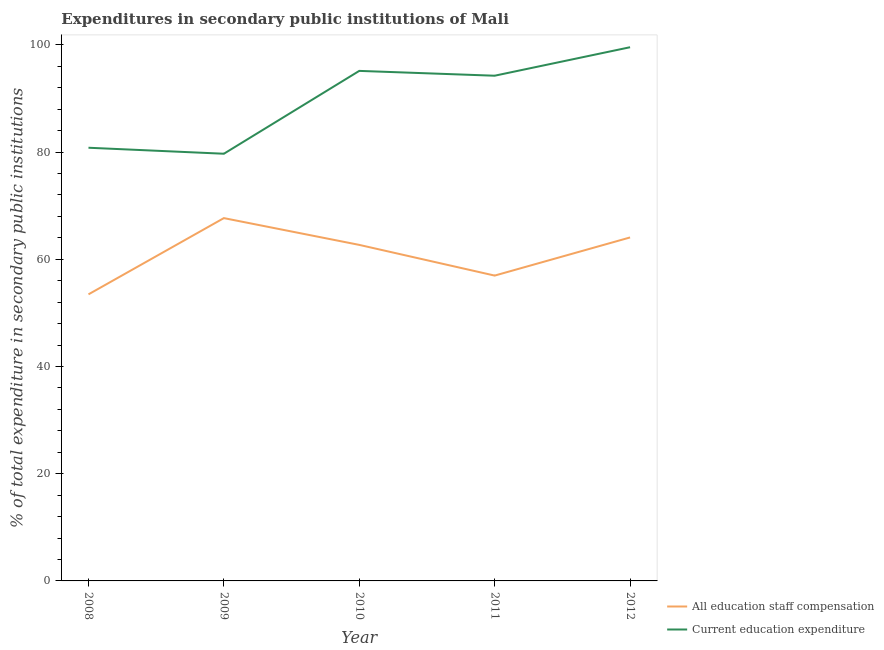How many different coloured lines are there?
Make the answer very short. 2. Is the number of lines equal to the number of legend labels?
Keep it short and to the point. Yes. What is the expenditure in staff compensation in 2012?
Make the answer very short. 64.07. Across all years, what is the maximum expenditure in education?
Offer a very short reply. 99.55. Across all years, what is the minimum expenditure in staff compensation?
Offer a terse response. 53.46. In which year was the expenditure in staff compensation minimum?
Provide a short and direct response. 2008. What is the total expenditure in education in the graph?
Provide a succinct answer. 449.43. What is the difference between the expenditure in staff compensation in 2008 and that in 2010?
Keep it short and to the point. -9.23. What is the difference between the expenditure in education in 2011 and the expenditure in staff compensation in 2009?
Offer a very short reply. 26.56. What is the average expenditure in education per year?
Your answer should be very brief. 89.89. In the year 2008, what is the difference between the expenditure in education and expenditure in staff compensation?
Offer a terse response. 27.35. What is the ratio of the expenditure in staff compensation in 2010 to that in 2012?
Ensure brevity in your answer.  0.98. Is the expenditure in education in 2008 less than that in 2010?
Your answer should be compact. Yes. What is the difference between the highest and the second highest expenditure in staff compensation?
Give a very brief answer. 3.61. What is the difference between the highest and the lowest expenditure in staff compensation?
Your answer should be compact. 14.22. In how many years, is the expenditure in education greater than the average expenditure in education taken over all years?
Make the answer very short. 3. How many years are there in the graph?
Give a very brief answer. 5. What is the difference between two consecutive major ticks on the Y-axis?
Keep it short and to the point. 20. Does the graph contain any zero values?
Your response must be concise. No. Does the graph contain grids?
Offer a very short reply. No. Where does the legend appear in the graph?
Make the answer very short. Bottom right. What is the title of the graph?
Your response must be concise. Expenditures in secondary public institutions of Mali. Does "Lower secondary rate" appear as one of the legend labels in the graph?
Your answer should be compact. No. What is the label or title of the Y-axis?
Give a very brief answer. % of total expenditure in secondary public institutions. What is the % of total expenditure in secondary public institutions of All education staff compensation in 2008?
Provide a short and direct response. 53.46. What is the % of total expenditure in secondary public institutions of Current education expenditure in 2008?
Your answer should be compact. 80.81. What is the % of total expenditure in secondary public institutions of All education staff compensation in 2009?
Your answer should be very brief. 67.68. What is the % of total expenditure in secondary public institutions in Current education expenditure in 2009?
Your answer should be very brief. 79.69. What is the % of total expenditure in secondary public institutions in All education staff compensation in 2010?
Your answer should be compact. 62.68. What is the % of total expenditure in secondary public institutions in Current education expenditure in 2010?
Offer a terse response. 95.14. What is the % of total expenditure in secondary public institutions in All education staff compensation in 2011?
Make the answer very short. 56.96. What is the % of total expenditure in secondary public institutions of Current education expenditure in 2011?
Your answer should be compact. 94.24. What is the % of total expenditure in secondary public institutions of All education staff compensation in 2012?
Your answer should be very brief. 64.07. What is the % of total expenditure in secondary public institutions of Current education expenditure in 2012?
Keep it short and to the point. 99.55. Across all years, what is the maximum % of total expenditure in secondary public institutions in All education staff compensation?
Keep it short and to the point. 67.68. Across all years, what is the maximum % of total expenditure in secondary public institutions in Current education expenditure?
Offer a terse response. 99.55. Across all years, what is the minimum % of total expenditure in secondary public institutions in All education staff compensation?
Make the answer very short. 53.46. Across all years, what is the minimum % of total expenditure in secondary public institutions in Current education expenditure?
Offer a terse response. 79.69. What is the total % of total expenditure in secondary public institutions of All education staff compensation in the graph?
Offer a terse response. 304.85. What is the total % of total expenditure in secondary public institutions in Current education expenditure in the graph?
Make the answer very short. 449.43. What is the difference between the % of total expenditure in secondary public institutions of All education staff compensation in 2008 and that in 2009?
Keep it short and to the point. -14.22. What is the difference between the % of total expenditure in secondary public institutions of Current education expenditure in 2008 and that in 2009?
Offer a very short reply. 1.12. What is the difference between the % of total expenditure in secondary public institutions of All education staff compensation in 2008 and that in 2010?
Ensure brevity in your answer.  -9.23. What is the difference between the % of total expenditure in secondary public institutions in Current education expenditure in 2008 and that in 2010?
Keep it short and to the point. -14.34. What is the difference between the % of total expenditure in secondary public institutions in All education staff compensation in 2008 and that in 2011?
Offer a terse response. -3.5. What is the difference between the % of total expenditure in secondary public institutions of Current education expenditure in 2008 and that in 2011?
Your answer should be very brief. -13.44. What is the difference between the % of total expenditure in secondary public institutions in All education staff compensation in 2008 and that in 2012?
Ensure brevity in your answer.  -10.62. What is the difference between the % of total expenditure in secondary public institutions in Current education expenditure in 2008 and that in 2012?
Your response must be concise. -18.75. What is the difference between the % of total expenditure in secondary public institutions of All education staff compensation in 2009 and that in 2010?
Ensure brevity in your answer.  5. What is the difference between the % of total expenditure in secondary public institutions of Current education expenditure in 2009 and that in 2010?
Offer a very short reply. -15.45. What is the difference between the % of total expenditure in secondary public institutions of All education staff compensation in 2009 and that in 2011?
Your answer should be compact. 10.72. What is the difference between the % of total expenditure in secondary public institutions of Current education expenditure in 2009 and that in 2011?
Offer a terse response. -14.55. What is the difference between the % of total expenditure in secondary public institutions in All education staff compensation in 2009 and that in 2012?
Provide a short and direct response. 3.61. What is the difference between the % of total expenditure in secondary public institutions in Current education expenditure in 2009 and that in 2012?
Provide a short and direct response. -19.87. What is the difference between the % of total expenditure in secondary public institutions of All education staff compensation in 2010 and that in 2011?
Your response must be concise. 5.73. What is the difference between the % of total expenditure in secondary public institutions of Current education expenditure in 2010 and that in 2011?
Provide a succinct answer. 0.9. What is the difference between the % of total expenditure in secondary public institutions of All education staff compensation in 2010 and that in 2012?
Offer a very short reply. -1.39. What is the difference between the % of total expenditure in secondary public institutions in Current education expenditure in 2010 and that in 2012?
Ensure brevity in your answer.  -4.41. What is the difference between the % of total expenditure in secondary public institutions in All education staff compensation in 2011 and that in 2012?
Provide a succinct answer. -7.11. What is the difference between the % of total expenditure in secondary public institutions in Current education expenditure in 2011 and that in 2012?
Your response must be concise. -5.31. What is the difference between the % of total expenditure in secondary public institutions in All education staff compensation in 2008 and the % of total expenditure in secondary public institutions in Current education expenditure in 2009?
Provide a succinct answer. -26.23. What is the difference between the % of total expenditure in secondary public institutions of All education staff compensation in 2008 and the % of total expenditure in secondary public institutions of Current education expenditure in 2010?
Your answer should be very brief. -41.69. What is the difference between the % of total expenditure in secondary public institutions of All education staff compensation in 2008 and the % of total expenditure in secondary public institutions of Current education expenditure in 2011?
Keep it short and to the point. -40.78. What is the difference between the % of total expenditure in secondary public institutions in All education staff compensation in 2008 and the % of total expenditure in secondary public institutions in Current education expenditure in 2012?
Make the answer very short. -46.1. What is the difference between the % of total expenditure in secondary public institutions of All education staff compensation in 2009 and the % of total expenditure in secondary public institutions of Current education expenditure in 2010?
Your answer should be compact. -27.46. What is the difference between the % of total expenditure in secondary public institutions of All education staff compensation in 2009 and the % of total expenditure in secondary public institutions of Current education expenditure in 2011?
Provide a short and direct response. -26.56. What is the difference between the % of total expenditure in secondary public institutions in All education staff compensation in 2009 and the % of total expenditure in secondary public institutions in Current education expenditure in 2012?
Offer a very short reply. -31.87. What is the difference between the % of total expenditure in secondary public institutions of All education staff compensation in 2010 and the % of total expenditure in secondary public institutions of Current education expenditure in 2011?
Make the answer very short. -31.56. What is the difference between the % of total expenditure in secondary public institutions in All education staff compensation in 2010 and the % of total expenditure in secondary public institutions in Current education expenditure in 2012?
Your answer should be very brief. -36.87. What is the difference between the % of total expenditure in secondary public institutions of All education staff compensation in 2011 and the % of total expenditure in secondary public institutions of Current education expenditure in 2012?
Keep it short and to the point. -42.6. What is the average % of total expenditure in secondary public institutions of All education staff compensation per year?
Your answer should be very brief. 60.97. What is the average % of total expenditure in secondary public institutions in Current education expenditure per year?
Provide a short and direct response. 89.89. In the year 2008, what is the difference between the % of total expenditure in secondary public institutions of All education staff compensation and % of total expenditure in secondary public institutions of Current education expenditure?
Keep it short and to the point. -27.35. In the year 2009, what is the difference between the % of total expenditure in secondary public institutions in All education staff compensation and % of total expenditure in secondary public institutions in Current education expenditure?
Keep it short and to the point. -12.01. In the year 2010, what is the difference between the % of total expenditure in secondary public institutions in All education staff compensation and % of total expenditure in secondary public institutions in Current education expenditure?
Offer a very short reply. -32.46. In the year 2011, what is the difference between the % of total expenditure in secondary public institutions of All education staff compensation and % of total expenditure in secondary public institutions of Current education expenditure?
Ensure brevity in your answer.  -37.28. In the year 2012, what is the difference between the % of total expenditure in secondary public institutions in All education staff compensation and % of total expenditure in secondary public institutions in Current education expenditure?
Keep it short and to the point. -35.48. What is the ratio of the % of total expenditure in secondary public institutions of All education staff compensation in 2008 to that in 2009?
Keep it short and to the point. 0.79. What is the ratio of the % of total expenditure in secondary public institutions in All education staff compensation in 2008 to that in 2010?
Keep it short and to the point. 0.85. What is the ratio of the % of total expenditure in secondary public institutions in Current education expenditure in 2008 to that in 2010?
Your answer should be compact. 0.85. What is the ratio of the % of total expenditure in secondary public institutions in All education staff compensation in 2008 to that in 2011?
Ensure brevity in your answer.  0.94. What is the ratio of the % of total expenditure in secondary public institutions of Current education expenditure in 2008 to that in 2011?
Offer a very short reply. 0.86. What is the ratio of the % of total expenditure in secondary public institutions in All education staff compensation in 2008 to that in 2012?
Your answer should be very brief. 0.83. What is the ratio of the % of total expenditure in secondary public institutions of Current education expenditure in 2008 to that in 2012?
Provide a succinct answer. 0.81. What is the ratio of the % of total expenditure in secondary public institutions of All education staff compensation in 2009 to that in 2010?
Offer a very short reply. 1.08. What is the ratio of the % of total expenditure in secondary public institutions of Current education expenditure in 2009 to that in 2010?
Your answer should be compact. 0.84. What is the ratio of the % of total expenditure in secondary public institutions in All education staff compensation in 2009 to that in 2011?
Give a very brief answer. 1.19. What is the ratio of the % of total expenditure in secondary public institutions in Current education expenditure in 2009 to that in 2011?
Keep it short and to the point. 0.85. What is the ratio of the % of total expenditure in secondary public institutions in All education staff compensation in 2009 to that in 2012?
Provide a succinct answer. 1.06. What is the ratio of the % of total expenditure in secondary public institutions in Current education expenditure in 2009 to that in 2012?
Offer a terse response. 0.8. What is the ratio of the % of total expenditure in secondary public institutions in All education staff compensation in 2010 to that in 2011?
Provide a succinct answer. 1.1. What is the ratio of the % of total expenditure in secondary public institutions of Current education expenditure in 2010 to that in 2011?
Give a very brief answer. 1.01. What is the ratio of the % of total expenditure in secondary public institutions of All education staff compensation in 2010 to that in 2012?
Make the answer very short. 0.98. What is the ratio of the % of total expenditure in secondary public institutions of Current education expenditure in 2010 to that in 2012?
Your answer should be very brief. 0.96. What is the ratio of the % of total expenditure in secondary public institutions of All education staff compensation in 2011 to that in 2012?
Ensure brevity in your answer.  0.89. What is the ratio of the % of total expenditure in secondary public institutions in Current education expenditure in 2011 to that in 2012?
Ensure brevity in your answer.  0.95. What is the difference between the highest and the second highest % of total expenditure in secondary public institutions in All education staff compensation?
Ensure brevity in your answer.  3.61. What is the difference between the highest and the second highest % of total expenditure in secondary public institutions of Current education expenditure?
Offer a very short reply. 4.41. What is the difference between the highest and the lowest % of total expenditure in secondary public institutions of All education staff compensation?
Your answer should be compact. 14.22. What is the difference between the highest and the lowest % of total expenditure in secondary public institutions in Current education expenditure?
Your response must be concise. 19.87. 